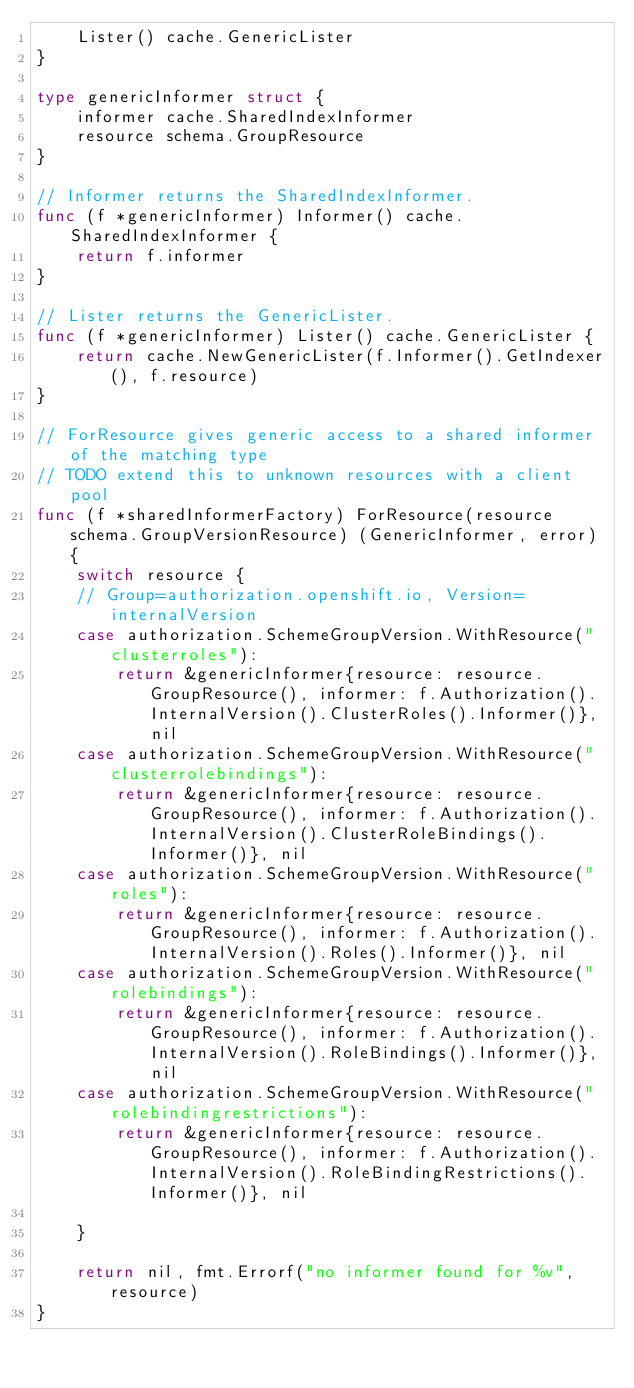Convert code to text. <code><loc_0><loc_0><loc_500><loc_500><_Go_>	Lister() cache.GenericLister
}

type genericInformer struct {
	informer cache.SharedIndexInformer
	resource schema.GroupResource
}

// Informer returns the SharedIndexInformer.
func (f *genericInformer) Informer() cache.SharedIndexInformer {
	return f.informer
}

// Lister returns the GenericLister.
func (f *genericInformer) Lister() cache.GenericLister {
	return cache.NewGenericLister(f.Informer().GetIndexer(), f.resource)
}

// ForResource gives generic access to a shared informer of the matching type
// TODO extend this to unknown resources with a client pool
func (f *sharedInformerFactory) ForResource(resource schema.GroupVersionResource) (GenericInformer, error) {
	switch resource {
	// Group=authorization.openshift.io, Version=internalVersion
	case authorization.SchemeGroupVersion.WithResource("clusterroles"):
		return &genericInformer{resource: resource.GroupResource(), informer: f.Authorization().InternalVersion().ClusterRoles().Informer()}, nil
	case authorization.SchemeGroupVersion.WithResource("clusterrolebindings"):
		return &genericInformer{resource: resource.GroupResource(), informer: f.Authorization().InternalVersion().ClusterRoleBindings().Informer()}, nil
	case authorization.SchemeGroupVersion.WithResource("roles"):
		return &genericInformer{resource: resource.GroupResource(), informer: f.Authorization().InternalVersion().Roles().Informer()}, nil
	case authorization.SchemeGroupVersion.WithResource("rolebindings"):
		return &genericInformer{resource: resource.GroupResource(), informer: f.Authorization().InternalVersion().RoleBindings().Informer()}, nil
	case authorization.SchemeGroupVersion.WithResource("rolebindingrestrictions"):
		return &genericInformer{resource: resource.GroupResource(), informer: f.Authorization().InternalVersion().RoleBindingRestrictions().Informer()}, nil

	}

	return nil, fmt.Errorf("no informer found for %v", resource)
}
</code> 